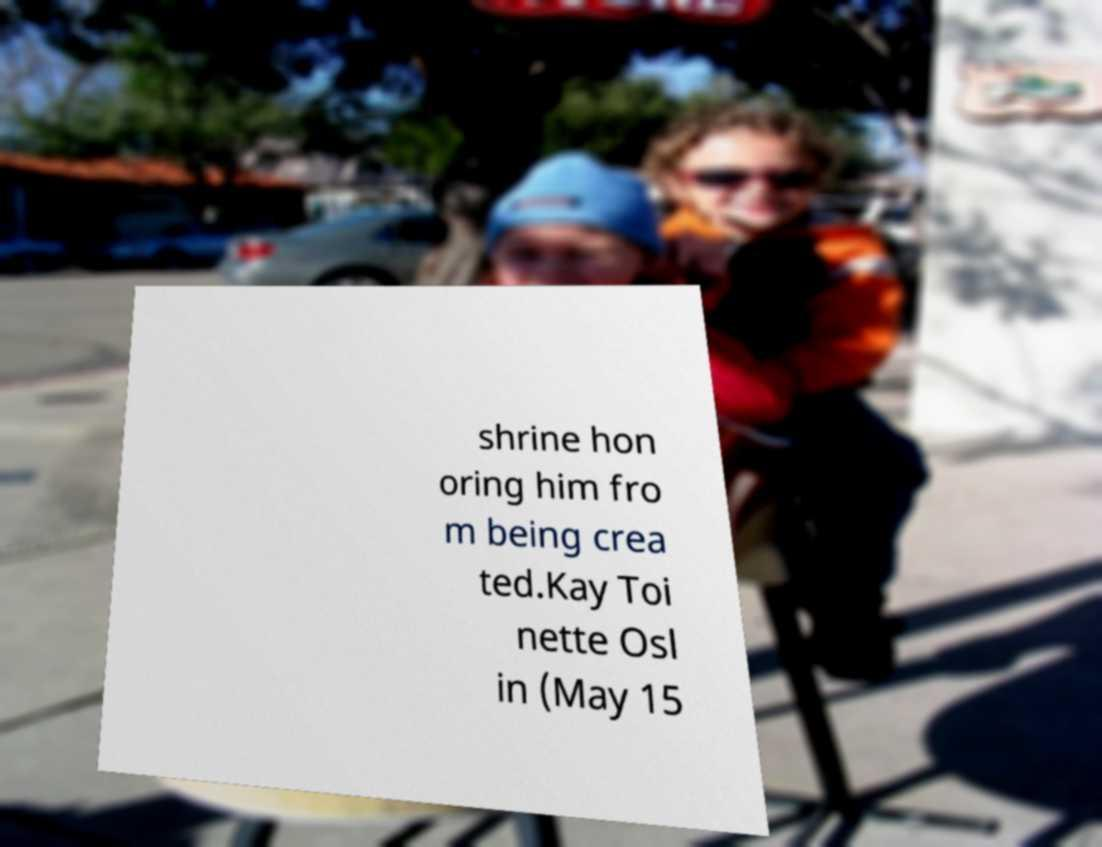There's text embedded in this image that I need extracted. Can you transcribe it verbatim? shrine hon oring him fro m being crea ted.Kay Toi nette Osl in (May 15 